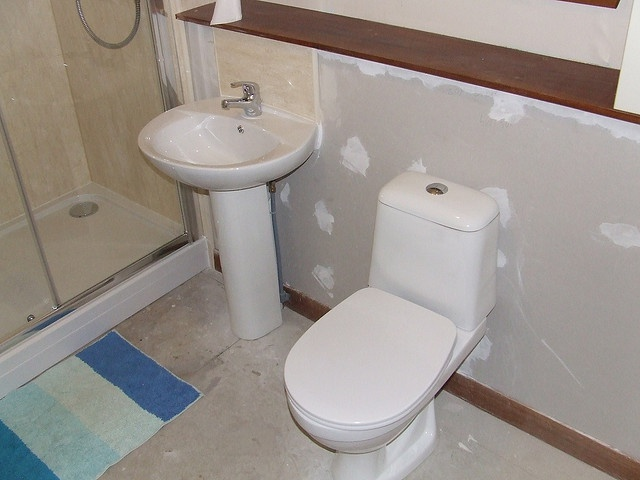Describe the objects in this image and their specific colors. I can see toilet in gray, lightgray, and darkgray tones and sink in gray, darkgray, and lightgray tones in this image. 